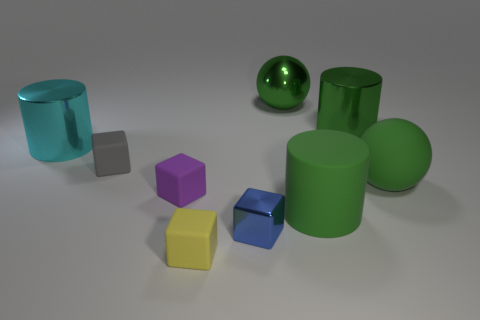What is the material of the other sphere that is the same color as the large shiny ball?
Provide a succinct answer. Rubber. Is the shape of the metallic object that is left of the tiny yellow cube the same as the metallic thing that is in front of the gray rubber thing?
Provide a succinct answer. No. How many other things are there of the same color as the small metal cube?
Your answer should be compact. 0. There is a large ball behind the large green sphere that is in front of the matte block that is left of the purple rubber block; what is it made of?
Provide a succinct answer. Metal. What is the material of the big green sphere behind the metal cylinder behind the big cyan object?
Give a very brief answer. Metal. Is the number of large cyan objects that are on the right side of the tiny shiny cube less than the number of big cyan shiny cylinders?
Make the answer very short. Yes. There is a metallic object that is in front of the cyan metal cylinder; what shape is it?
Give a very brief answer. Cube. Do the gray matte block and the metal object that is in front of the tiny purple block have the same size?
Your response must be concise. Yes. Is there a yellow thing that has the same material as the tiny purple thing?
Make the answer very short. Yes. How many cylinders are either tiny matte things or green objects?
Give a very brief answer. 2. 